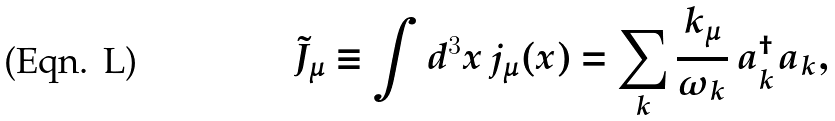<formula> <loc_0><loc_0><loc_500><loc_500>\tilde { J } _ { \mu } \equiv \int d ^ { 3 } x \, j _ { \mu } ( x ) = \sum _ { k } \frac { k _ { \mu } } { \omega _ { k } } \, a ^ { \dagger } _ { k } a _ { k } ,</formula> 